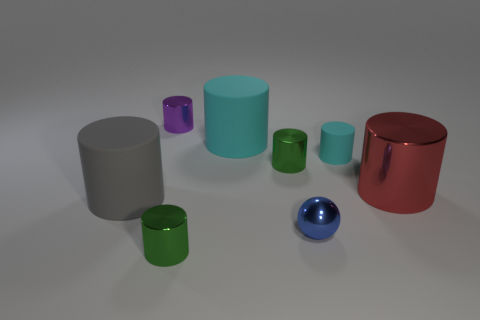Subtract all gray cylinders. How many cylinders are left? 6 Subtract 2 cylinders. How many cylinders are left? 5 Subtract all red cylinders. How many cylinders are left? 6 Subtract all blue cylinders. Subtract all green cubes. How many cylinders are left? 7 Subtract all balls. How many objects are left? 7 Add 1 small cyan cylinders. How many objects exist? 9 Subtract all red metal cylinders. Subtract all big gray cylinders. How many objects are left? 6 Add 8 tiny cyan rubber things. How many tiny cyan rubber things are left? 9 Add 4 large things. How many large things exist? 7 Subtract 0 cyan spheres. How many objects are left? 8 